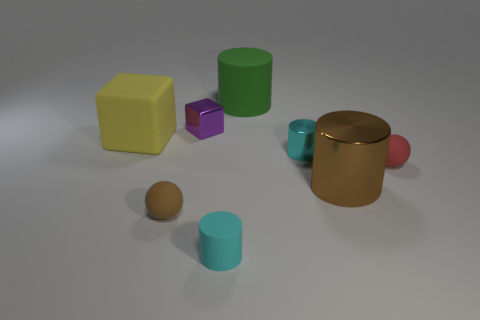The large matte block is what color? yellow 